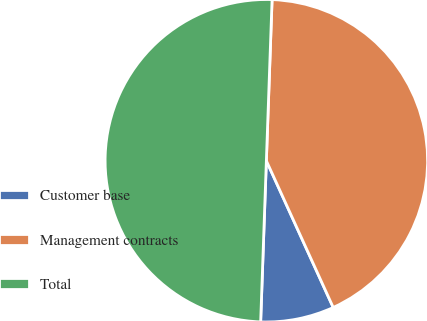Convert chart to OTSL. <chart><loc_0><loc_0><loc_500><loc_500><pie_chart><fcel>Customer base<fcel>Management contracts<fcel>Total<nl><fcel>7.37%<fcel>42.63%<fcel>50.0%<nl></chart> 